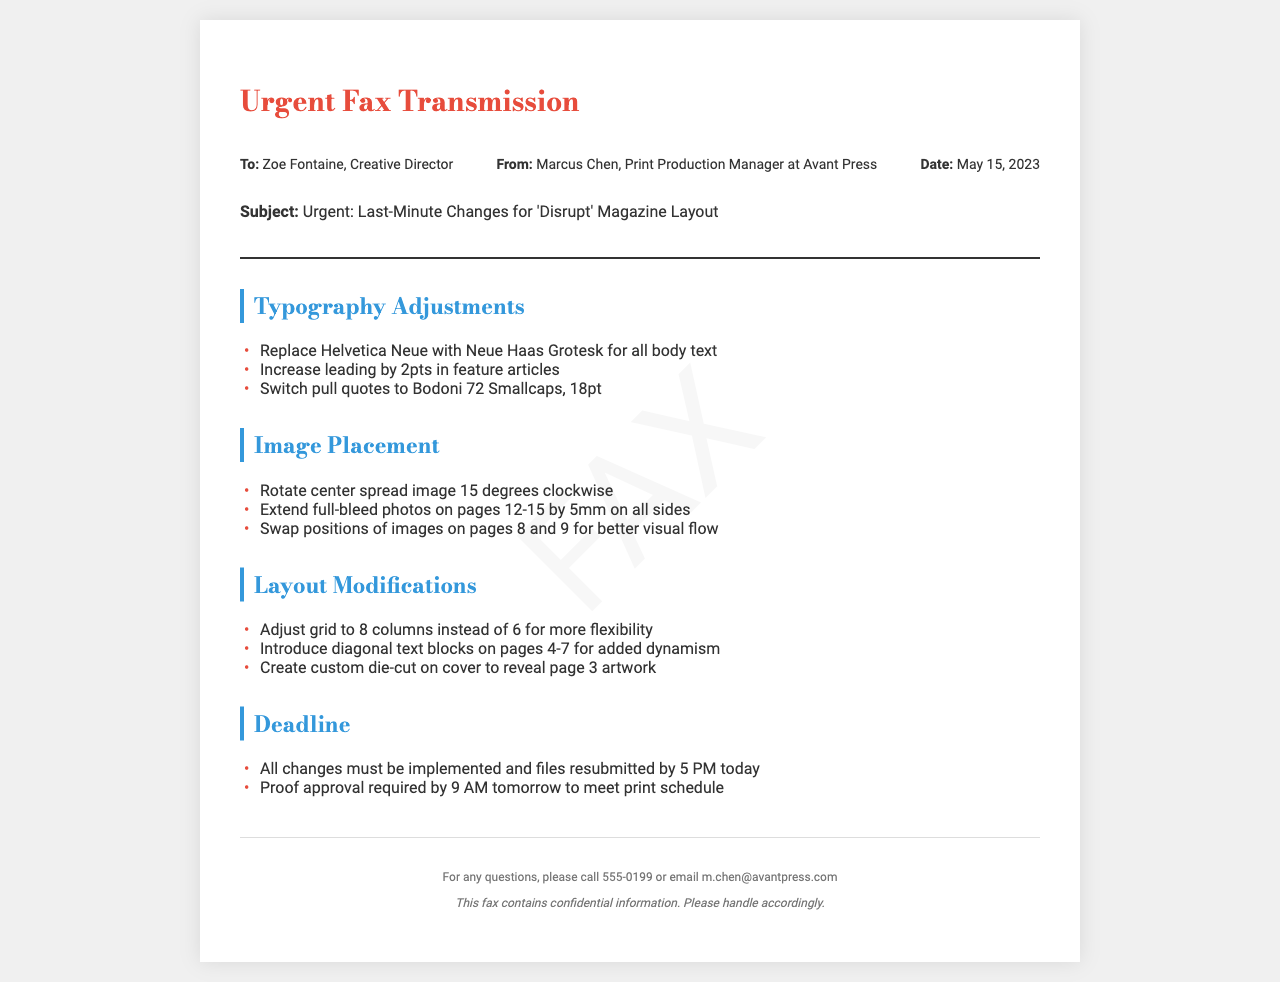what is the subject of the fax? The subject is specified in the document, indicating what the fax is about.
Answer: Urgent: Last-Minute Changes for 'Disrupt' Magazine Layout who is the sender of the fax? The sender's name is provided in the header section of the document, identifying who is transmitting the fax.
Answer: Marcus Chen what changes are requested for the body text typography? The document specifies a particular change in typography for the body text.
Answer: Replace Helvetica Neue with Neue Haas Grotesk by how many points should the leading be increased in feature articles? The document explicitly mentions the amount of leading increase specified for feature articles.
Answer: 2pts what is the deadline for resubmitting the files? The deadline for changes to be completed and files resubmitted is clearly stated in the document.
Answer: 5 PM today which pages have modifications for image placement? The document lists specific pages that require adjustments for images, indicating where changes will be made.
Answer: pages 12-15 how many columns should the grid be adjusted to? The suggested adjustment for the grid is mentioned in the layout modifications section of the fax.
Answer: 8 columns what type of text blocks are introduced on pages 4-7? The document indicates a specific style of text blocks being introduced, contributing to the layout changes.
Answer: diagonal text blocks what is the required proof approval time? The document states the time by which proof approval must be completed to adhere to the schedule.
Answer: 9 AM tomorrow 